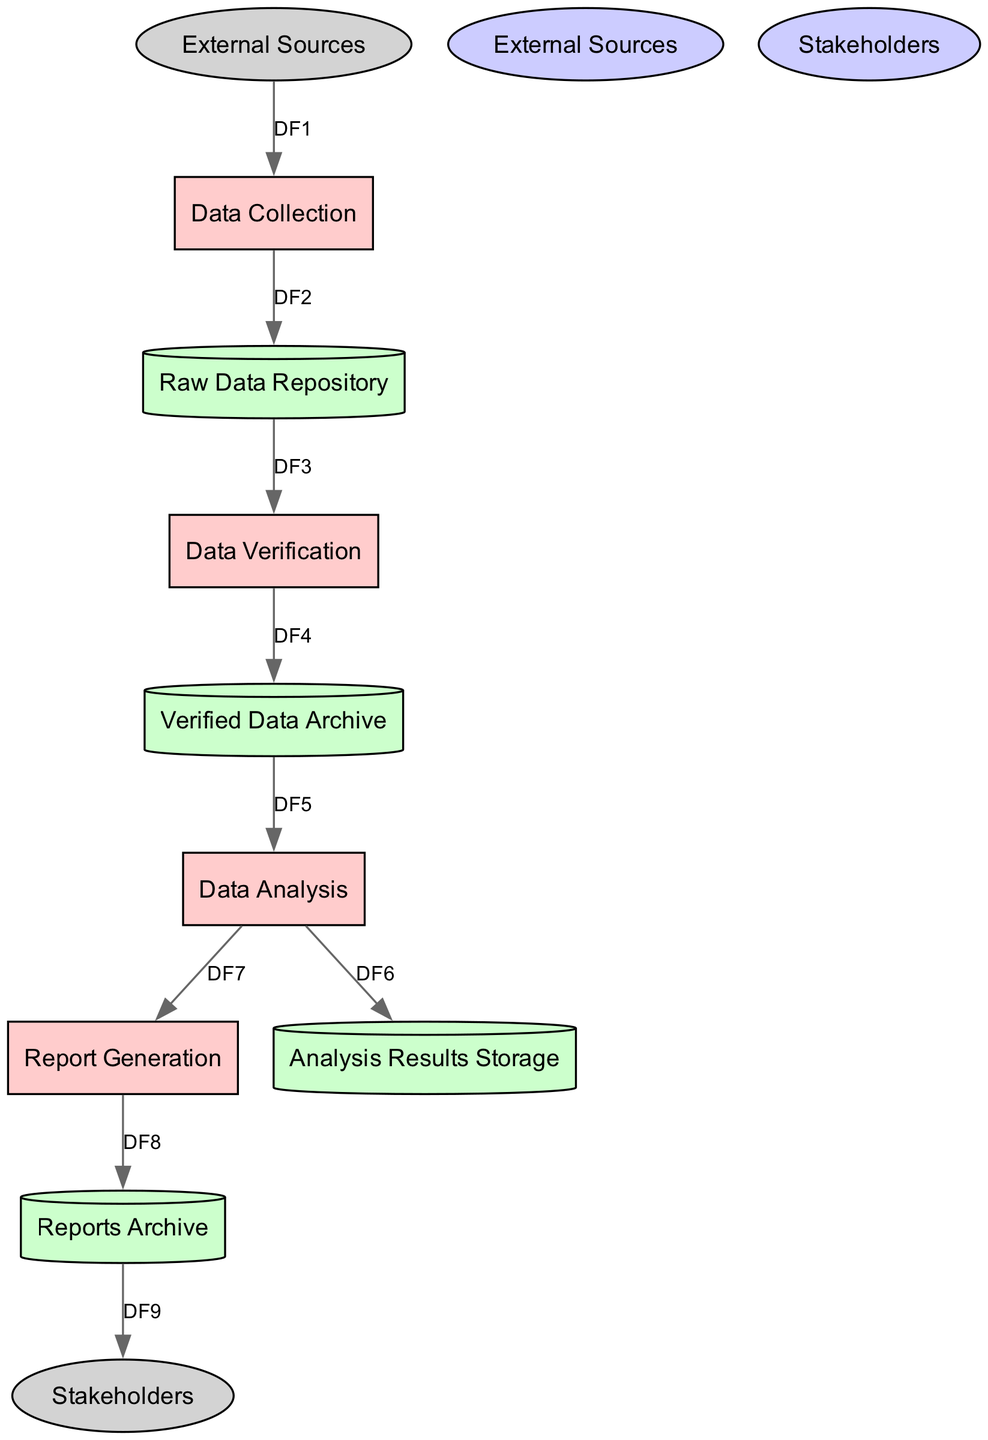What is the first process in the diagram? The first process in the data flow is "Data Collection," which gathers data from various sources.
Answer: Data Collection How many data stores are present in the diagram? Counting the total number of data stores listed, there are four: Raw Data Repository, Verified Data Archive, Analysis Results Storage, and Reports Archive.
Answer: 4 What type of flow occurs from the raw data repository to the data verification process? The flow from the raw data repository (DS1) to the data verification process (P2) is described as the flow of raw data proceeding to be verified.
Answer: Flow of raw data Which external entity provides data to the data collection process? The external entity that provides data to the data collection process is "External Sources," including news agencies and NGOs.
Answer: External Sources In which data store are the generated reports saved? The generated reports are saved in the "Reports Archive," which is specifically designated for storing reports and summaries.
Answer: Reports Archive What is the last process before reports are sent to stakeholders? The last process before reports are sent to stakeholders is "Report Generation," which compiles the analysis results into comprehensive reports.
Answer: Report Generation After data verification, where is the verified data stored? The verified data is stored in the "Verified Data Archive," where it is kept after the validation process is completed.
Answer: Verified Data Archive What type of data flow occurs from the analysis to the report generation? The data flow from analysis results (P3) to the report generation process (P4) is described as the flow of analysis results needed for generating reports.
Answer: Flow of analysis results Which data store is used to store analysis results? The data store used for storing analysis results is "Analysis Results Storage," which holds findings from the analysis process.
Answer: Analysis Results Storage 